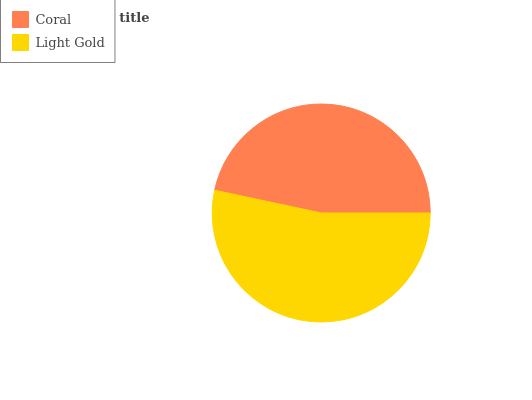Is Coral the minimum?
Answer yes or no. Yes. Is Light Gold the maximum?
Answer yes or no. Yes. Is Light Gold the minimum?
Answer yes or no. No. Is Light Gold greater than Coral?
Answer yes or no. Yes. Is Coral less than Light Gold?
Answer yes or no. Yes. Is Coral greater than Light Gold?
Answer yes or no. No. Is Light Gold less than Coral?
Answer yes or no. No. Is Light Gold the high median?
Answer yes or no. Yes. Is Coral the low median?
Answer yes or no. Yes. Is Coral the high median?
Answer yes or no. No. Is Light Gold the low median?
Answer yes or no. No. 